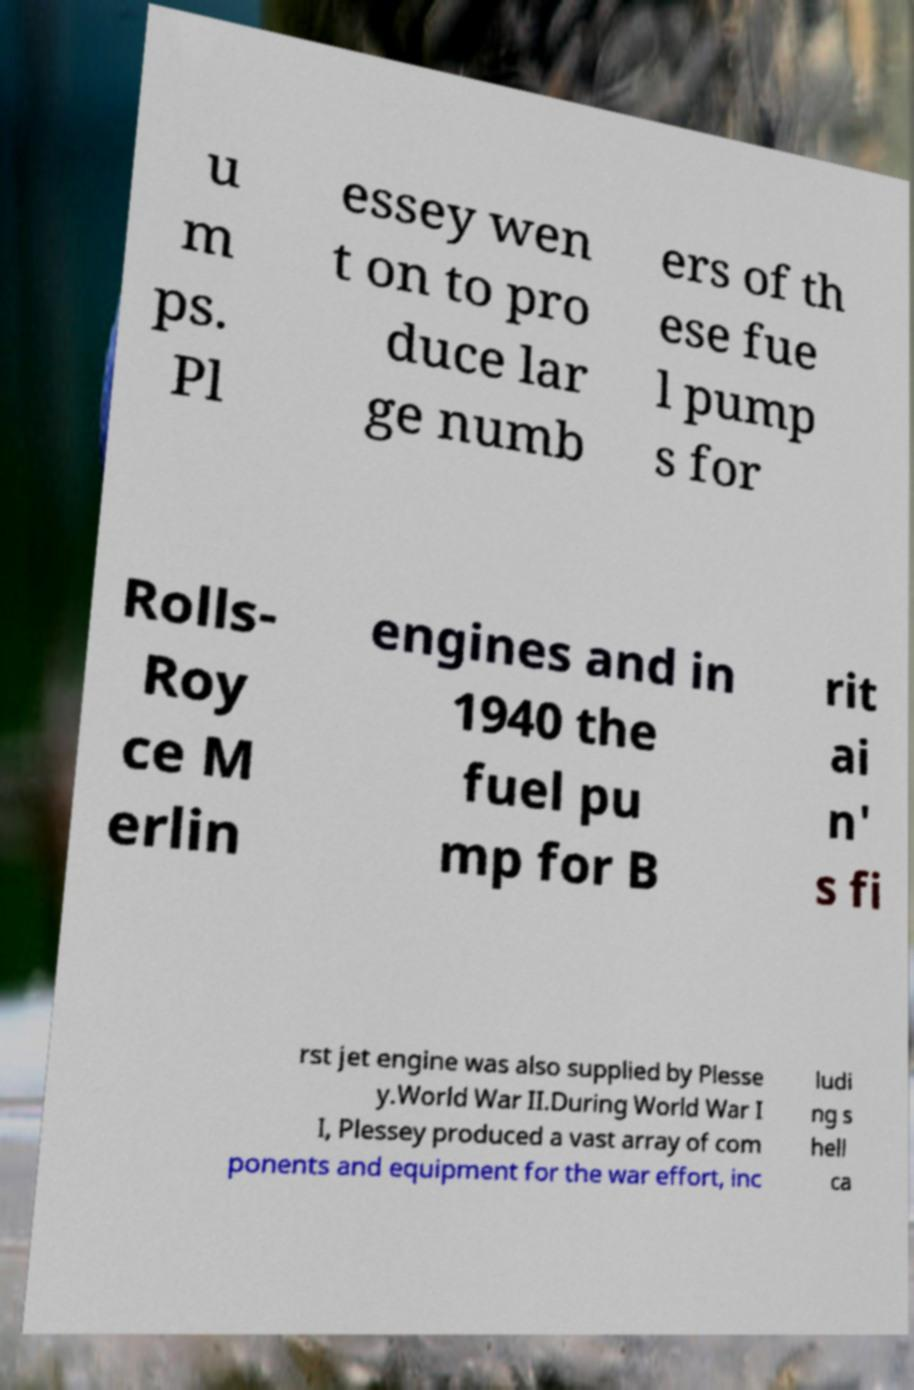Please identify and transcribe the text found in this image. u m ps. Pl essey wen t on to pro duce lar ge numb ers of th ese fue l pump s for Rolls- Roy ce M erlin engines and in 1940 the fuel pu mp for B rit ai n' s fi rst jet engine was also supplied by Plesse y.World War II.During World War I I, Plessey produced a vast array of com ponents and equipment for the war effort, inc ludi ng s hell ca 